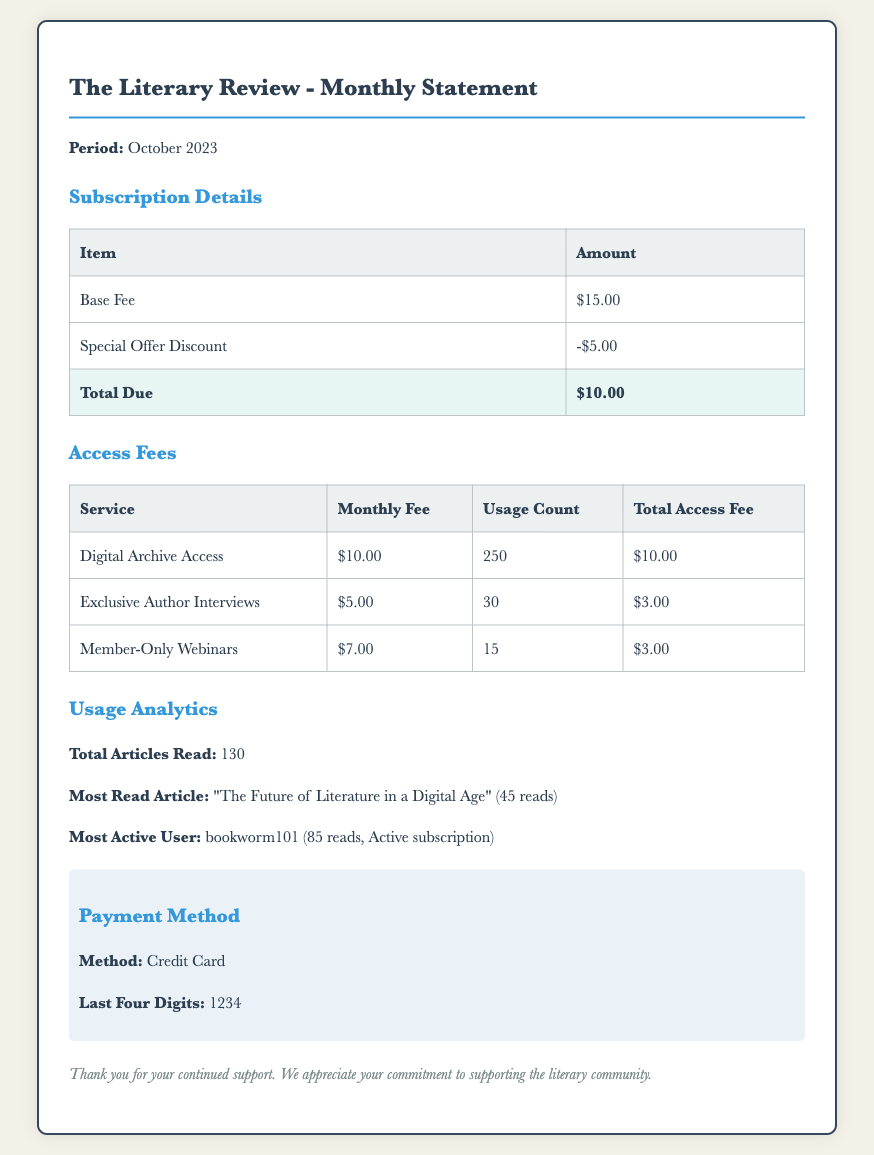What is the period of this statement? The period of the statement is explicitly mentioned in the document as "October 2023."
Answer: October 2023 What is the base fee for the subscription? The document provides the base fee amount in the subscription details section, which is "$15.00."
Answer: $15.00 How much is the special offer discount? The amount for the special offer discount can be found in the subscription details section, which is "-$5.00."
Answer: -$5.00 What is the total amount due? The total amount due is highlighted in the subscription details section of the document as "$10.00."
Answer: $10.00 How many articles were read in total? The total articles read is specified in the usage analytics section of the document as "130."
Answer: 130 What was the most read article? The document lists the most read article as "The Future of Literature in a Digital Age."
Answer: The Future of Literature in a Digital Age Who is the most active user? The most active user is mentioned in the usage analytics section, identified as "bookworm101."
Answer: bookworm101 What is the payment method used? The payment method is detailed in the payment information section, stating "Credit Card."
Answer: Credit Card How many digital archive accesses occurred? The usage count for digital archive access is indicated in the access fees section as "250."
Answer: 250 